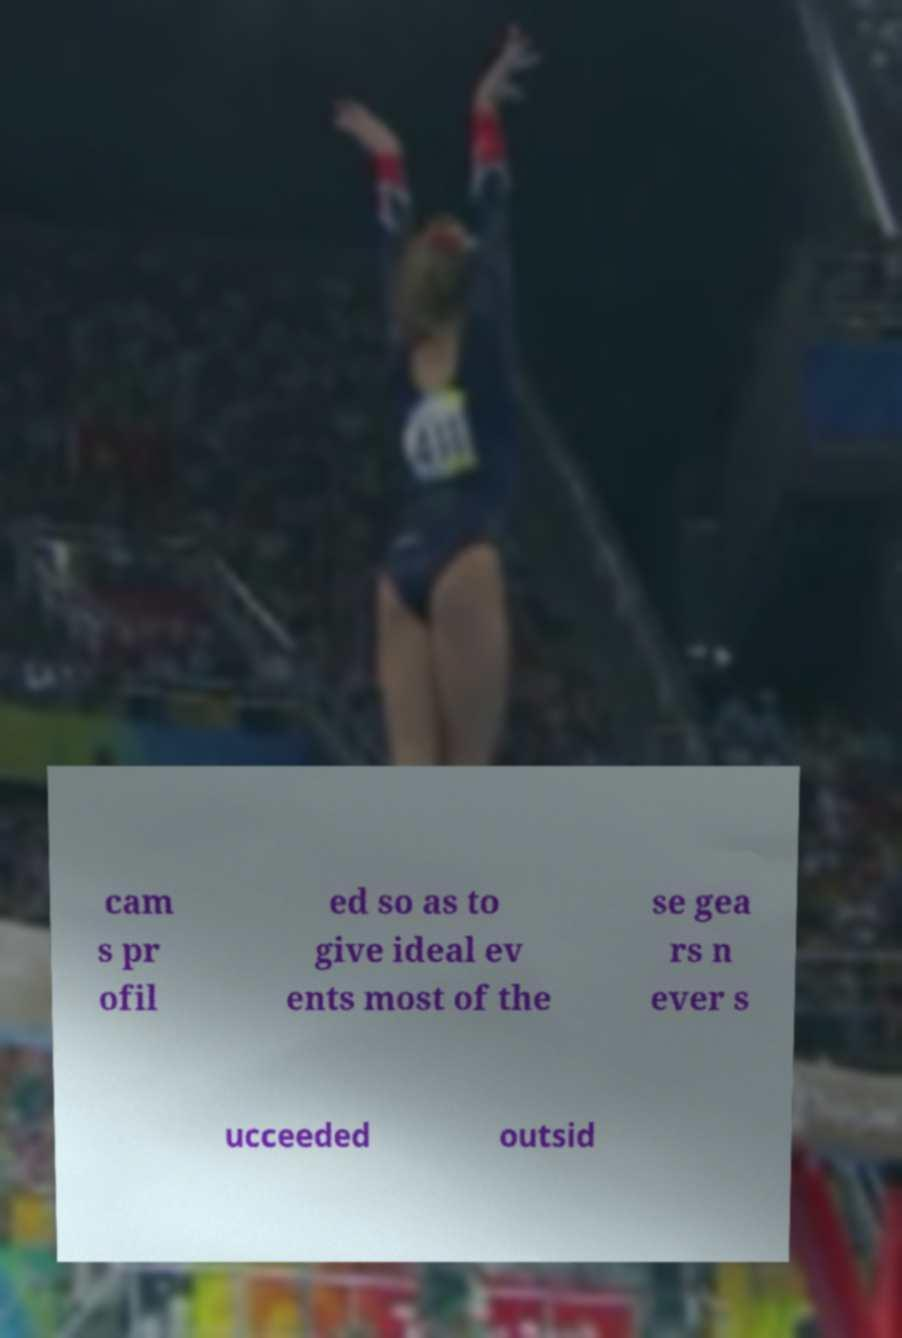Can you read and provide the text displayed in the image?This photo seems to have some interesting text. Can you extract and type it out for me? cam s pr ofil ed so as to give ideal ev ents most of the se gea rs n ever s ucceeded outsid 